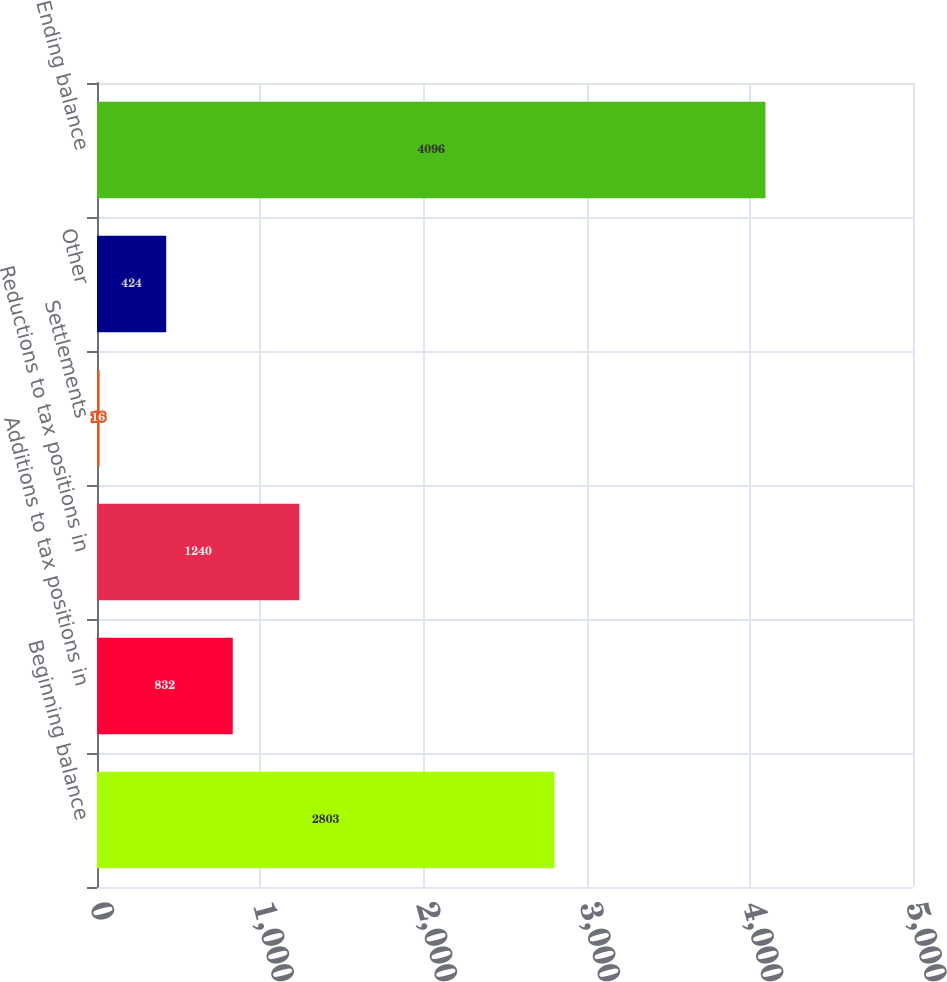Convert chart to OTSL. <chart><loc_0><loc_0><loc_500><loc_500><bar_chart><fcel>Beginning balance<fcel>Additions to tax positions in<fcel>Reductions to tax positions in<fcel>Settlements<fcel>Other<fcel>Ending balance<nl><fcel>2803<fcel>832<fcel>1240<fcel>16<fcel>424<fcel>4096<nl></chart> 